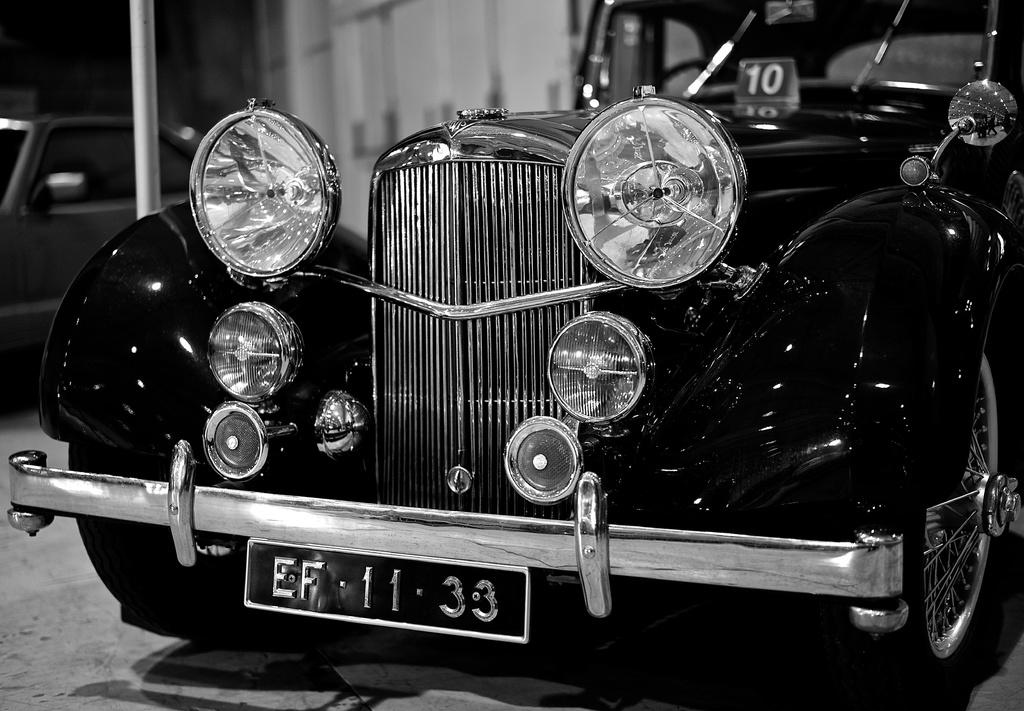What is the color scheme of the image? The image is black and white. What is the main subject in the foreground of the image? There is a car in the foreground of the image. How many ice cubes are visible in the image? There are no ice cubes present in the image, as it is a black and white image of a car in the foreground. What part of the car is visible in the image? The entire car is visible in the image, as it is in the foreground. 